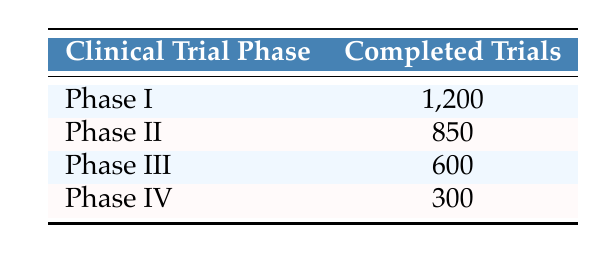What is the total number of completed trials across all phases? To find the total number of completed trials, we need to sum the completed trials from all phases: 1200 (Phase I) + 850 (Phase II) + 600 (Phase III) + 300 (Phase IV) = 2950.
Answer: 2950 Which phase has the highest number of completed trials? By looking at the completed trials listed, Phase I has 1200 completed trials, which is higher than the other phases (Phase II: 850, Phase III: 600, Phase IV: 300).
Answer: Phase I Is the number of completed trials in Phase IV greater than that in Phase III? Phase IV has 300 completed trials, while Phase III has 600 completed trials. Since 300 is not greater than 600, the statement is false.
Answer: No What is the difference in the number of completed trials between Phase I and Phase IV? The difference is calculated by subtracting the number of completed trials in Phase IV from Phase I: 1200 (Phase I) - 300 (Phase IV) = 900.
Answer: 900 What percentage of the total completed trials does Phase II represent? First, we need to calculate the total completed trials, which is 2950. Then, to find the percentage for Phase II, we calculate (850 / 2950) * 100 ≈ 28.78%.
Answer: Approximately 28.78% Which phase has the least number of completed trials? By comparing the completed trials listed, Phase IV has the least completed trials with a count of 300, which is lower than the other phases.
Answer: Phase IV Is the number of completed trials in Phase II greater than the combined total of Phase III and Phase IV? The combined total of Phase III and IV is 600 + 300 = 900. Since Phase II has 850 completed trials, this indicates 850 is not greater than 900.
Answer: No What are the completed trials for Phase III and Phase IV combined? To get the combined trials for Phase III and IV, we sum the completed trials: 600 (Phase III) + 300 (Phase IV) = 900.
Answer: 900 